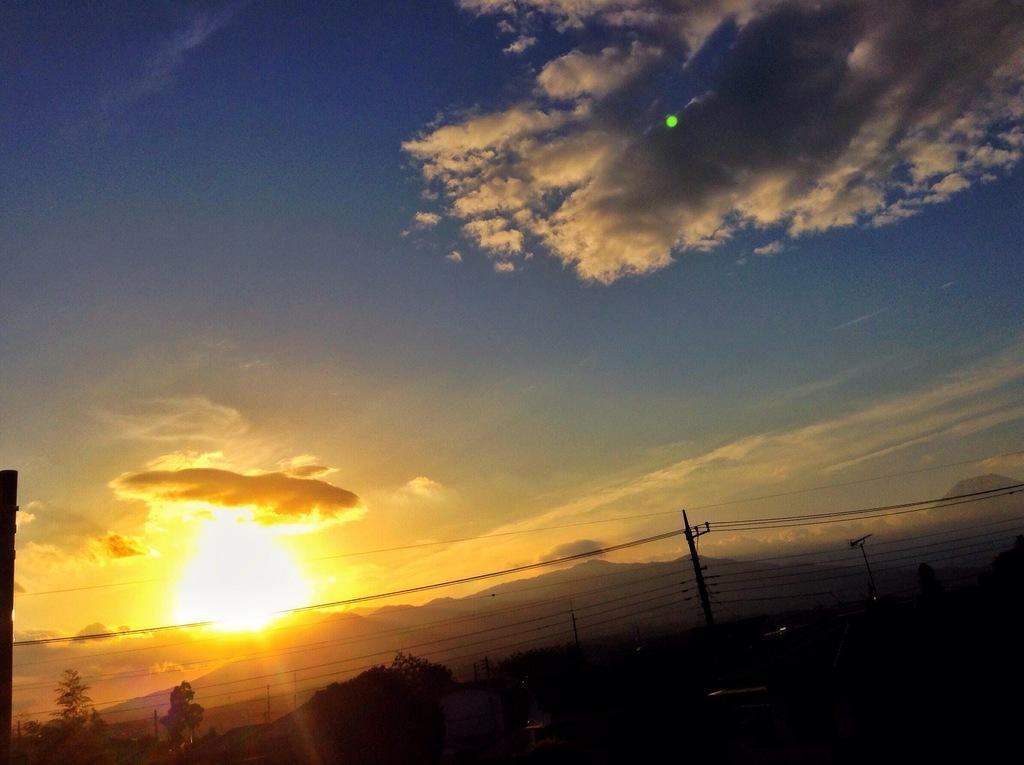In one or two sentences, can you explain what this image depicts? In this image we can see poles, wires, trees, and mountain. In the background we can see sky with clouds and sun. 